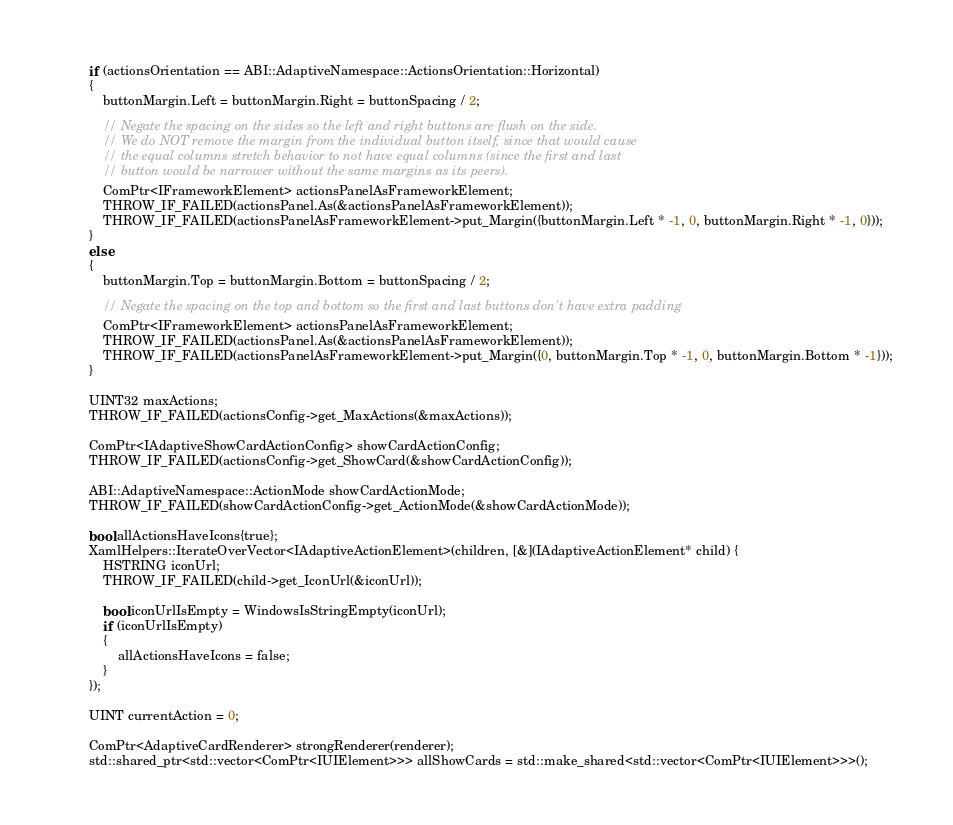Convert code to text. <code><loc_0><loc_0><loc_500><loc_500><_C++_>        if (actionsOrientation == ABI::AdaptiveNamespace::ActionsOrientation::Horizontal)
        {
            buttonMargin.Left = buttonMargin.Right = buttonSpacing / 2;

            // Negate the spacing on the sides so the left and right buttons are flush on the side.
            // We do NOT remove the margin from the individual button itself, since that would cause
            // the equal columns stretch behavior to not have equal columns (since the first and last
            // button would be narrower without the same margins as its peers).
            ComPtr<IFrameworkElement> actionsPanelAsFrameworkElement;
            THROW_IF_FAILED(actionsPanel.As(&actionsPanelAsFrameworkElement));
            THROW_IF_FAILED(actionsPanelAsFrameworkElement->put_Margin({buttonMargin.Left * -1, 0, buttonMargin.Right * -1, 0}));
        }
        else
        {
            buttonMargin.Top = buttonMargin.Bottom = buttonSpacing / 2;

            // Negate the spacing on the top and bottom so the first and last buttons don't have extra padding
            ComPtr<IFrameworkElement> actionsPanelAsFrameworkElement;
            THROW_IF_FAILED(actionsPanel.As(&actionsPanelAsFrameworkElement));
            THROW_IF_FAILED(actionsPanelAsFrameworkElement->put_Margin({0, buttonMargin.Top * -1, 0, buttonMargin.Bottom * -1}));
        }

        UINT32 maxActions;
        THROW_IF_FAILED(actionsConfig->get_MaxActions(&maxActions));

        ComPtr<IAdaptiveShowCardActionConfig> showCardActionConfig;
        THROW_IF_FAILED(actionsConfig->get_ShowCard(&showCardActionConfig));

        ABI::AdaptiveNamespace::ActionMode showCardActionMode;
        THROW_IF_FAILED(showCardActionConfig->get_ActionMode(&showCardActionMode));

        bool allActionsHaveIcons{true};
        XamlHelpers::IterateOverVector<IAdaptiveActionElement>(children, [&](IAdaptiveActionElement* child) {
            HSTRING iconUrl;
            THROW_IF_FAILED(child->get_IconUrl(&iconUrl));

            bool iconUrlIsEmpty = WindowsIsStringEmpty(iconUrl);
            if (iconUrlIsEmpty)
            {
                allActionsHaveIcons = false;
            }
        });

        UINT currentAction = 0;

        ComPtr<AdaptiveCardRenderer> strongRenderer(renderer);
        std::shared_ptr<std::vector<ComPtr<IUIElement>>> allShowCards = std::make_shared<std::vector<ComPtr<IUIElement>>>();</code> 